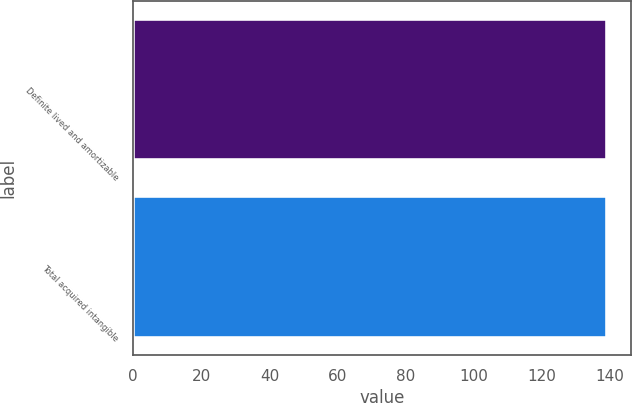Convert chart to OTSL. <chart><loc_0><loc_0><loc_500><loc_500><bar_chart><fcel>Definite lived and amortizable<fcel>Total acquired intangible<nl><fcel>139<fcel>139.1<nl></chart> 